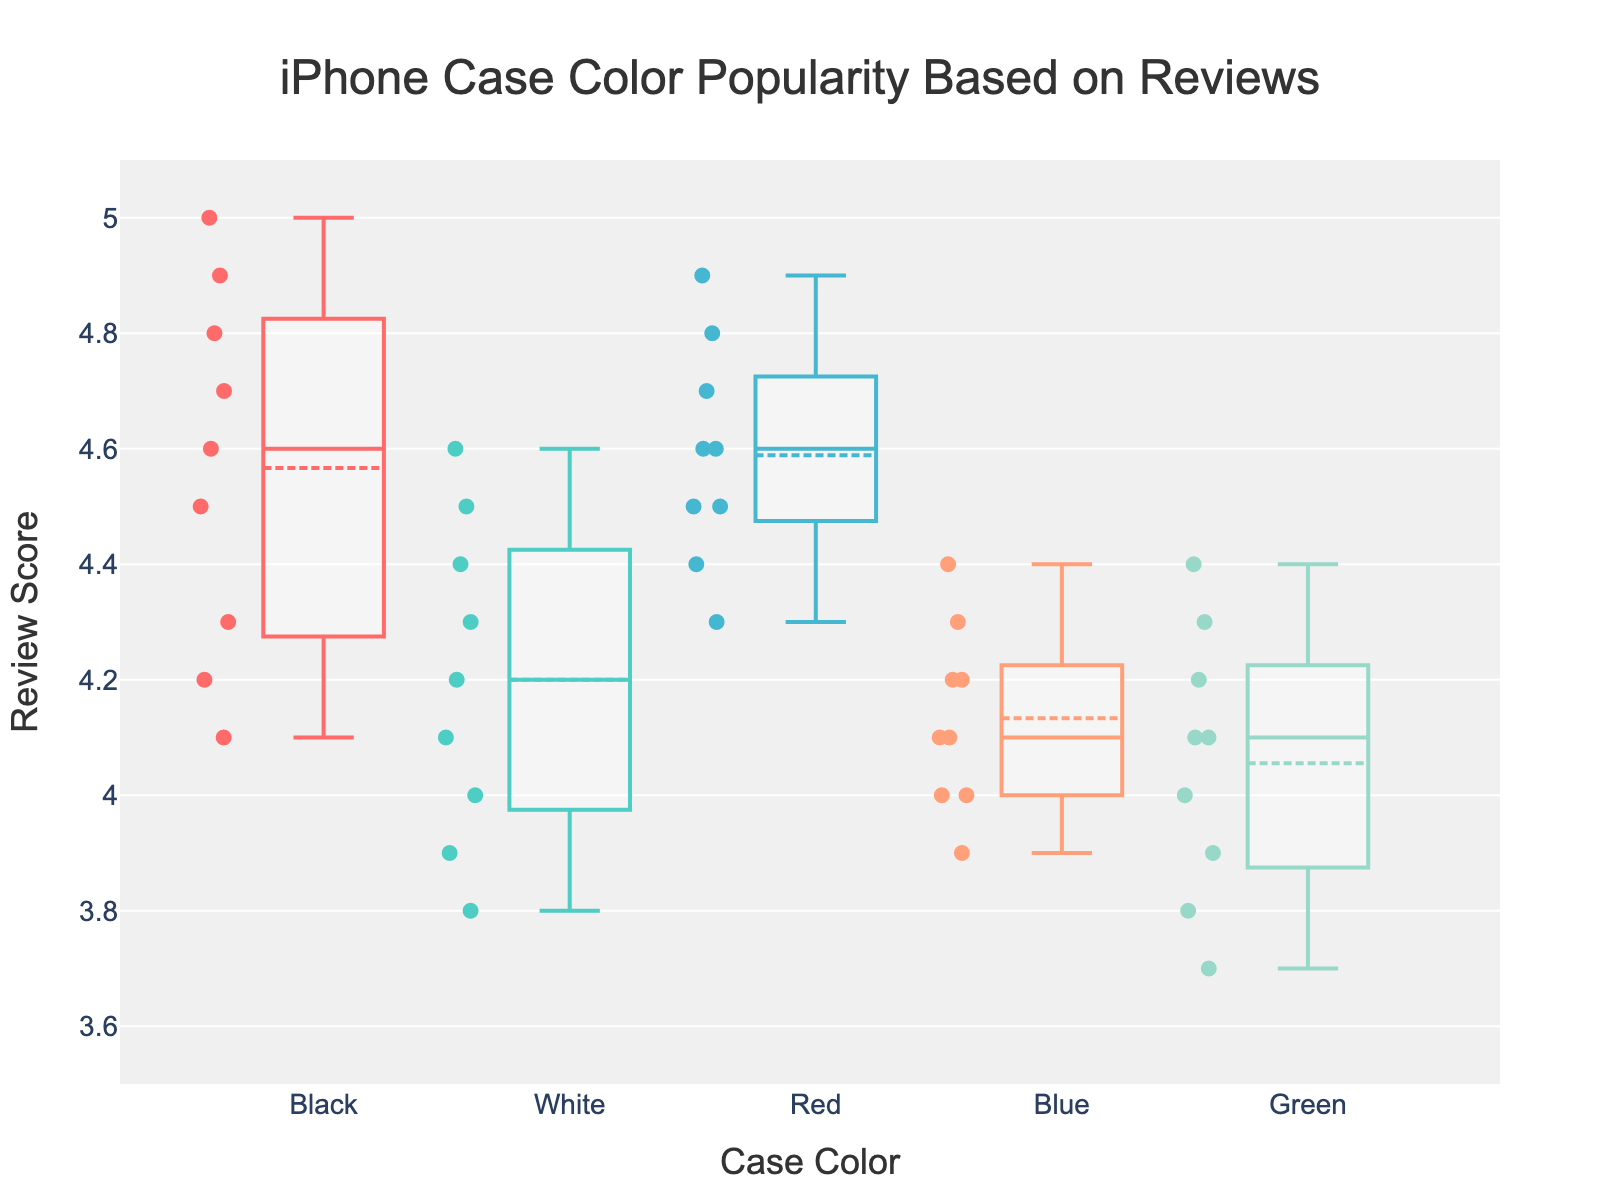What's the median review score for the Black iPhone cases? The median is the value separating the higher half from the lower half of the data. In a box plot, the median is shown as the central line in the box. For Black cases, locate this central line and read the corresponding score.
Answer: 4.5 Which iPhone case color has the highest median review score? To find the color with the highest median review score, compare the central line (median) of each box plot. The one that is highest on the y-axis corresponds to the highest median.
Answer: Red How do the interquartile ranges (IQR) of the Blue and White case reviews compare? The IQR is the range between the first quartile (bottom of the box) and the third quartile (top of the box). Compare the height of the boxes for Blue and White cases to determine which has a smaller or larger IQR.
Answer: White has a larger IQR than Blue Which iPhone case color has the least variability in review scores? Variability can be assessed by looking at the height of the box (IQR) and the range of whiskers in each box plot. The case color with the smallest box and shortest whiskers indicates the least variability.
Answer: Blue Are there any outliers for the Red iPhone case reviews? Outliers in a box plot are represented by individual points situated outside the whiskers. Examine the Red case plot to see if there are any such points.
Answer: No Which case color has the most consistent high ratings? Consistent high ratings mean small variability and generally high review scores. Look for the box plot with a high median and short range of whiskers concentrated towards the top of the y-axis.
Answer: Red What's the range of review scores for Green iPhone cases? The range is the difference between the maximum and minimum values. Identify the lowest and highest points (tips of the whiskers) in the Green case plot and subtract the smallest value from the largest.
Answer: 3.7 to 4.4 How does the review score distribution for White cases compare to Black cases? Compare the position and spread of the box and whiskers of the White and Black cases. Note their medians, IQRs, and ranges to discuss how the distributions differ.
Answer: White has a slightly lower median and a wider IQR than Black What is the average review score for the Blue cases? Add up all individual review scores for Blue cases and divide by the number of reviews to find the average.
Answer: 4.0 Which color has the widest review score distribution, and how can you tell? The widest distribution is indicated by the box plot with the longest whiskers and the tallest box (largest IQR). Compare these elements across all color plots.
Answer: Green 